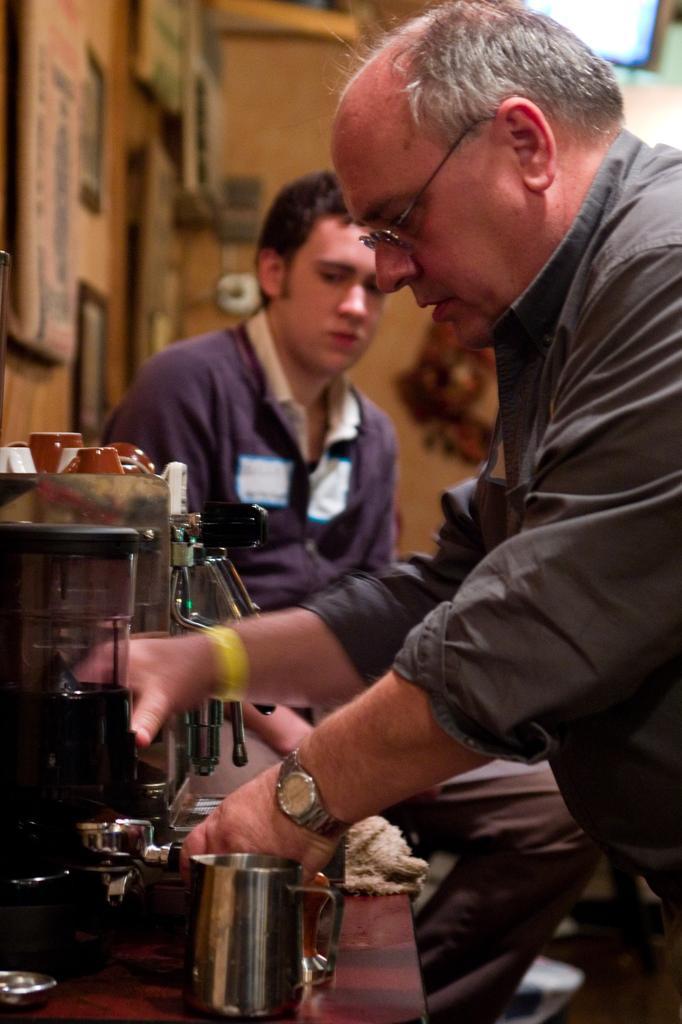Could you give a brief overview of what you see in this image? In this image there is a person holding a cup. Before him there is a table having coffee vending machine. There are cuts on the coffee vending machine. Bottom of the image there is a jar and few objects on the table. There is a person sitting on the chair. Few frames are attached to the wall. Right top there is a light attached to the wall. 